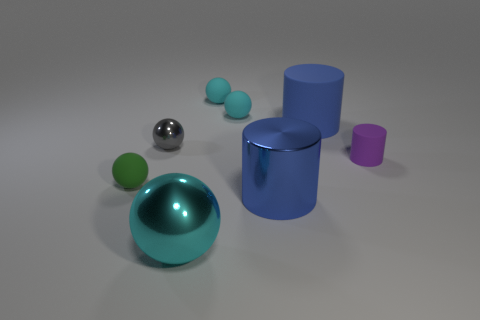Subtract all cyan cylinders. How many cyan spheres are left? 3 Subtract all metal balls. How many balls are left? 3 Subtract all gray balls. How many balls are left? 4 Add 1 small purple cylinders. How many objects exist? 9 Subtract all brown cylinders. Subtract all yellow blocks. How many cylinders are left? 3 Subtract all balls. How many objects are left? 3 Add 2 small things. How many small things exist? 7 Subtract 0 red balls. How many objects are left? 8 Subtract all small gray metallic cylinders. Subtract all metallic cylinders. How many objects are left? 7 Add 7 large blue metallic cylinders. How many large blue metallic cylinders are left? 8 